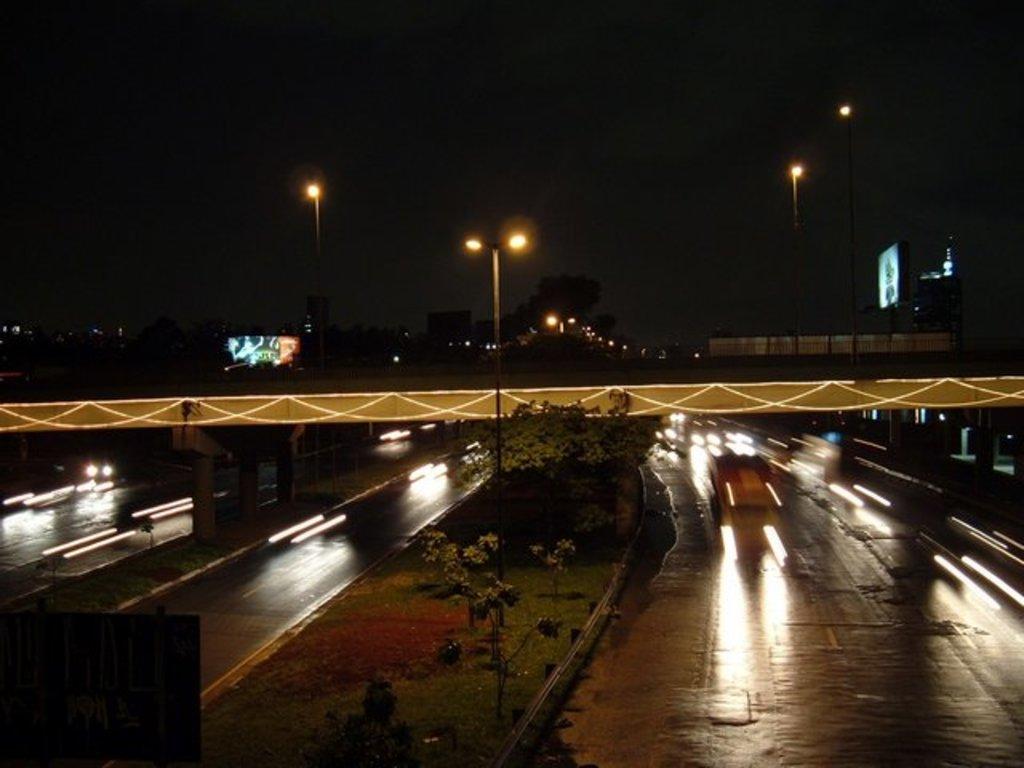Describe this image in one or two sentences. Background portion of the picture is dark. In this picture we can see a bridge, lights, poles, trees, grass, road dividers, pillars and few objects. On the right side of the picture it's blurry and it looks like a vehicle on the road. 